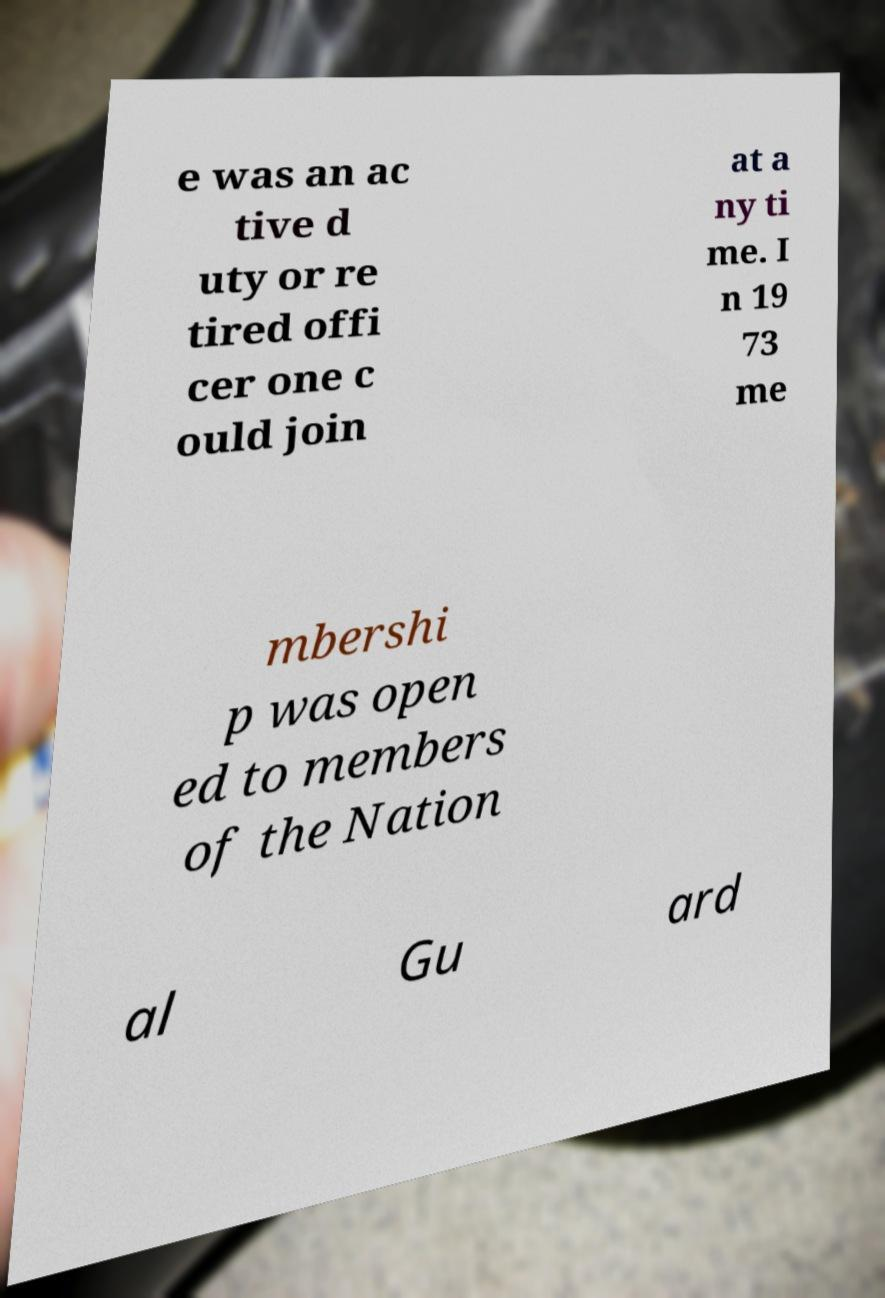What messages or text are displayed in this image? I need them in a readable, typed format. e was an ac tive d uty or re tired offi cer one c ould join at a ny ti me. I n 19 73 me mbershi p was open ed to members of the Nation al Gu ard 